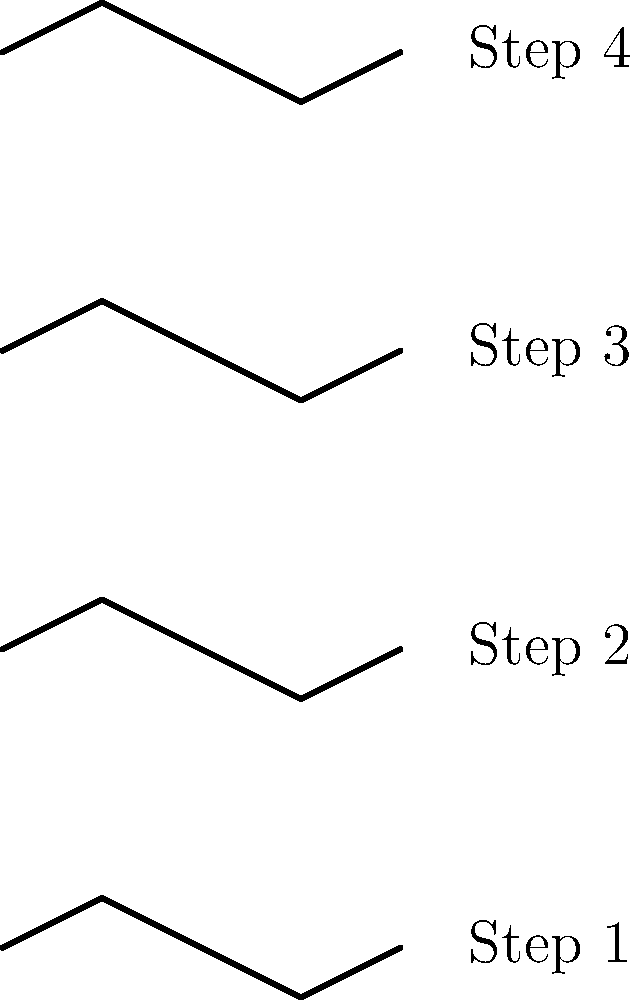Analyze the series of footprint diagrams representing four consecutive steps. Which gait abnormality is most likely represented by the consistent lateral deviation pattern observed? To identify the gait abnormality represented in the footprint diagrams, let's analyze the pattern step-by-step:

1. Observe the lateral deviation: Each footprint shows a consistent pattern of lateral movement from heel strike to toe-off.

2. Direction of deviation: The deviation is always to the right side (positive y-axis) during midstance, followed by a shift back towards the center line.

3. Consistency across steps: This pattern is repeated for all four steps, indicating a persistent abnormality rather than a temporary imbalance.

4. Magnitude of deviation: The lateral shift appears to be of similar magnitude in each step, suggesting a structural or neurological issue rather than pain avoidance.

5. Gait cycle analysis: The pattern shows an initial medial placement (towards the centerline), followed by a lateral shift (away from the centerline) during midstance, and then a return towards the centerline during toe-off.

6. Biomechanical interpretation: This pattern is consistent with overpronation, where the foot rolls inward excessively during the stance phase of the gait cycle.

7. Clinical significance: Overpronation can lead to various issues such as plantar fasciitis, shin splints, or knee pain due to the altered biomechanics of the lower limb.

Given these observations and analysis, the gait abnormality most likely represented by this consistent lateral deviation pattern is overpronation.
Answer: Overpronation 